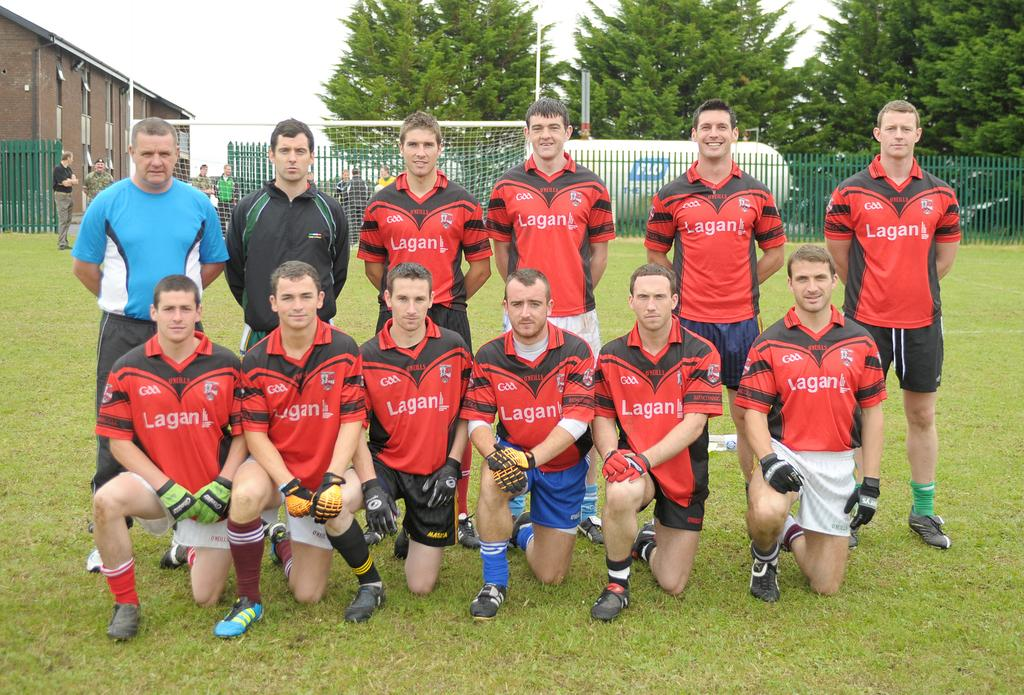What can be seen in the foreground of the image? There are men standing on the ground in the image. What is visible in the background of the image? Buildings, poles, a sportsnet, a wooden fence, trees, and the sky are visible in the background of the image. What type of pot is being used to lock the apparel in the image? There is no pot, lock, or apparel present in the image. 